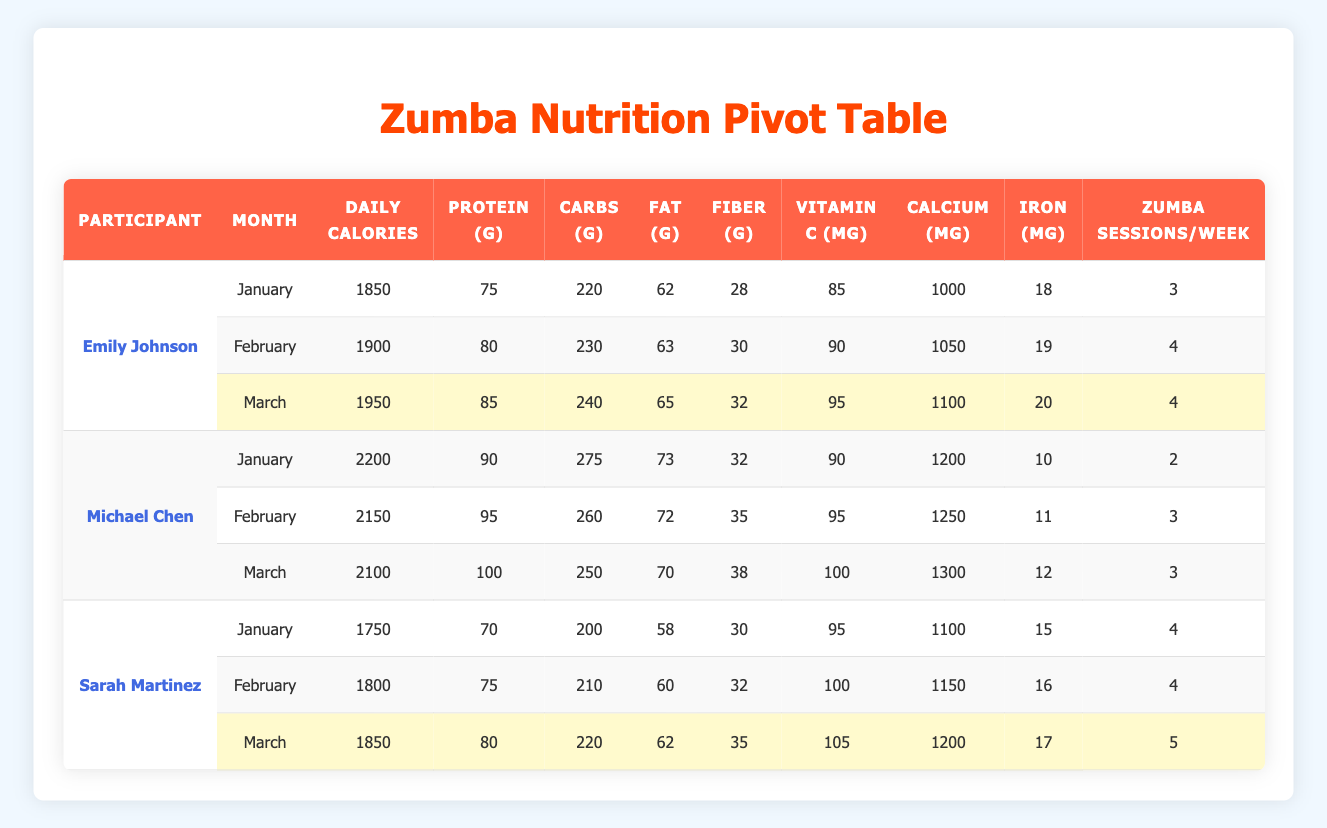What was Emily Johnson's daily calorie intake in March? Referring to the table, Emily Johnson's daily calorie intake in March is listed in the corresponding row, which shows 1950 calories.
Answer: 1950 What is the average protein intake of Sarah Martinez over the three months? To find the average protein intake, sum Sarah's protein intakes for January (70g), February (75g), and March (80g). The total is 70 + 75 + 80 = 225g. Then, divide by 3, giving an average of 225g / 3 = 75g.
Answer: 75 Did Michael Chen participate more in Zumba sessions in February than in January? Looking at the data, Michael Chen had 2 sessions in January and 3 sessions in February. Thus, the answer is yes, as 3 is greater than 2.
Answer: Yes Which participant had the highest fiber intake in March? By reviewing the March entries, Emily Johnson had a fiber intake of 32g, Michael Chen had 38g, and Sarah Martinez had 35g. Michael Chen has the highest intake at 38g.
Answer: Michael Chen What was the increase in calcium intake for Emily Johnson from January to March? Emily's calcium intake in January was 1000mg, and in March, it was 1100mg. The increase is calculated as 1100mg - 1000mg = 100mg.
Answer: 100 How many total Zumba sessions did Sarah Martinez attend from January to March? Sarah had 4 sessions in January, 4 in February, and 5 in March. Adding these together gives a total of 4 + 4 + 5 = 13 sessions over the three months.
Answer: 13 Was Emily Johnson's Vitamin C intake highest in February? Looking at the Vitamin C intake for Emily, in January it was 85mg, in February it was 90mg, and in March it was 95mg. Therefore, February was not the highest; March had the highest intake.
Answer: No Which month had the highest total daily calorie intake for all participants combined? For the total daily calorie intake, calculate the sum for each month: January (1850 + 2200 + 1750) = 5800, February (1900 + 2150 + 1800) = 5850, March (1950 + 2100 + 1850) = 5900. March has the highest total with 5900 calories.
Answer: March 